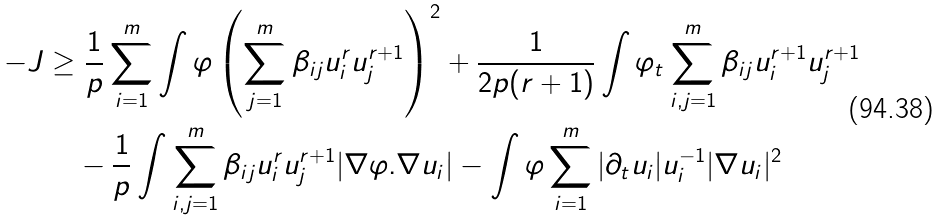Convert formula to latex. <formula><loc_0><loc_0><loc_500><loc_500>- J \geq & \ \frac { 1 } { p } \sum _ { i = 1 } ^ { m } \int \varphi \left ( \sum _ { j = 1 } ^ { m } \beta _ { i j } u _ { i } ^ { r } u _ { j } ^ { r + 1 } \right ) ^ { 2 } + \frac { 1 } { 2 p ( r + 1 ) } \int \varphi _ { t } \sum _ { i , j = 1 } ^ { m } \beta _ { i j } u _ { i } ^ { r + 1 } u _ { j } ^ { r + 1 } \\ & - \frac { 1 } { p } \int \sum _ { i , j = 1 } ^ { m } \beta _ { i j } u _ { i } ^ { r } u _ { j } ^ { r + 1 } | \nabla \varphi . \nabla u _ { i } | - \int \varphi \sum _ { i = 1 } ^ { m } | \partial _ { t } u _ { i } | u _ { i } ^ { - 1 } | \nabla u _ { i } | ^ { 2 }</formula> 